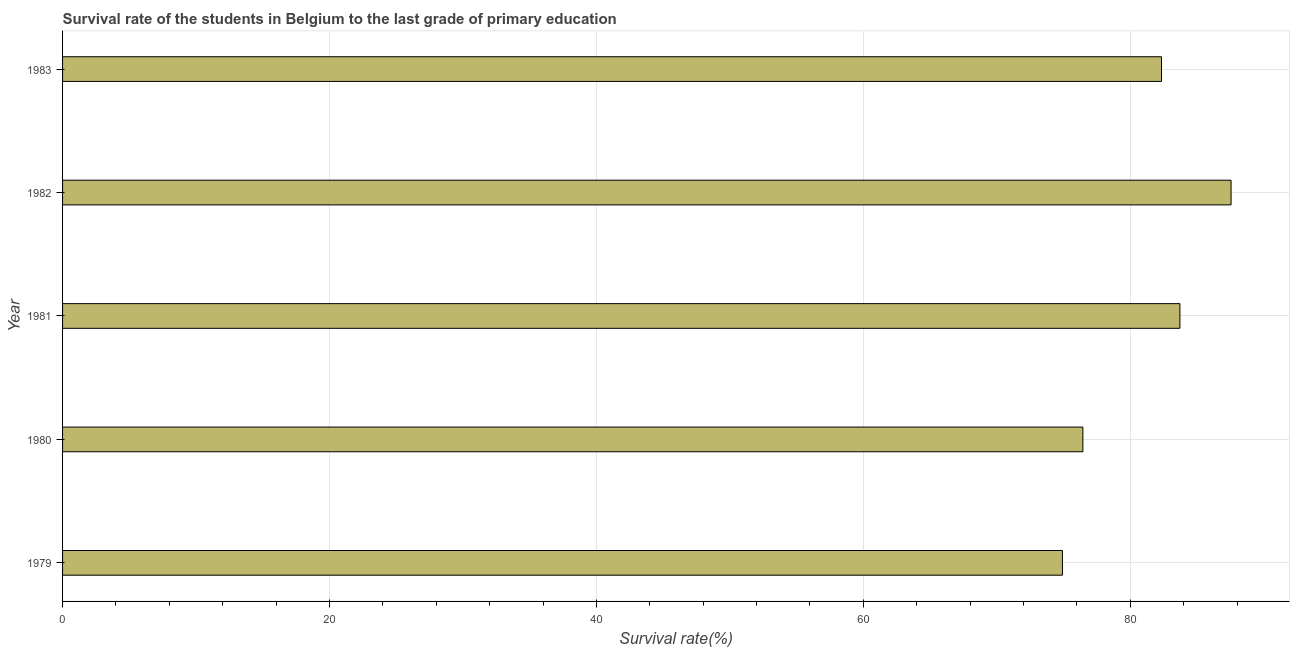Does the graph contain any zero values?
Provide a short and direct response. No. What is the title of the graph?
Make the answer very short. Survival rate of the students in Belgium to the last grade of primary education. What is the label or title of the X-axis?
Ensure brevity in your answer.  Survival rate(%). What is the label or title of the Y-axis?
Offer a terse response. Year. What is the survival rate in primary education in 1981?
Offer a terse response. 83.72. Across all years, what is the maximum survival rate in primary education?
Provide a succinct answer. 87.55. Across all years, what is the minimum survival rate in primary education?
Your response must be concise. 74.92. In which year was the survival rate in primary education minimum?
Give a very brief answer. 1979. What is the sum of the survival rate in primary education?
Offer a terse response. 404.99. What is the difference between the survival rate in primary education in 1979 and 1980?
Give a very brief answer. -1.53. What is the average survival rate in primary education per year?
Offer a terse response. 81. What is the median survival rate in primary education?
Ensure brevity in your answer.  82.34. Do a majority of the years between 1980 and 1981 (inclusive) have survival rate in primary education greater than 16 %?
Provide a short and direct response. Yes. Is the difference between the survival rate in primary education in 1980 and 1983 greater than the difference between any two years?
Keep it short and to the point. No. What is the difference between the highest and the second highest survival rate in primary education?
Give a very brief answer. 3.83. What is the difference between the highest and the lowest survival rate in primary education?
Your response must be concise. 12.63. In how many years, is the survival rate in primary education greater than the average survival rate in primary education taken over all years?
Your response must be concise. 3. How many bars are there?
Your answer should be compact. 5. How many years are there in the graph?
Make the answer very short. 5. What is the difference between two consecutive major ticks on the X-axis?
Make the answer very short. 20. Are the values on the major ticks of X-axis written in scientific E-notation?
Keep it short and to the point. No. What is the Survival rate(%) of 1979?
Your answer should be compact. 74.92. What is the Survival rate(%) in 1980?
Offer a terse response. 76.45. What is the Survival rate(%) of 1981?
Offer a terse response. 83.72. What is the Survival rate(%) of 1982?
Make the answer very short. 87.55. What is the Survival rate(%) in 1983?
Provide a succinct answer. 82.34. What is the difference between the Survival rate(%) in 1979 and 1980?
Provide a succinct answer. -1.53. What is the difference between the Survival rate(%) in 1979 and 1981?
Ensure brevity in your answer.  -8.8. What is the difference between the Survival rate(%) in 1979 and 1982?
Give a very brief answer. -12.63. What is the difference between the Survival rate(%) in 1979 and 1983?
Your answer should be very brief. -7.42. What is the difference between the Survival rate(%) in 1980 and 1981?
Your response must be concise. -7.27. What is the difference between the Survival rate(%) in 1980 and 1982?
Ensure brevity in your answer.  -11.1. What is the difference between the Survival rate(%) in 1980 and 1983?
Give a very brief answer. -5.89. What is the difference between the Survival rate(%) in 1981 and 1982?
Keep it short and to the point. -3.83. What is the difference between the Survival rate(%) in 1981 and 1983?
Your answer should be very brief. 1.38. What is the difference between the Survival rate(%) in 1982 and 1983?
Offer a terse response. 5.21. What is the ratio of the Survival rate(%) in 1979 to that in 1981?
Ensure brevity in your answer.  0.9. What is the ratio of the Survival rate(%) in 1979 to that in 1982?
Your response must be concise. 0.86. What is the ratio of the Survival rate(%) in 1979 to that in 1983?
Give a very brief answer. 0.91. What is the ratio of the Survival rate(%) in 1980 to that in 1982?
Your answer should be very brief. 0.87. What is the ratio of the Survival rate(%) in 1980 to that in 1983?
Ensure brevity in your answer.  0.93. What is the ratio of the Survival rate(%) in 1981 to that in 1982?
Provide a short and direct response. 0.96. What is the ratio of the Survival rate(%) in 1981 to that in 1983?
Provide a succinct answer. 1.02. What is the ratio of the Survival rate(%) in 1982 to that in 1983?
Keep it short and to the point. 1.06. 